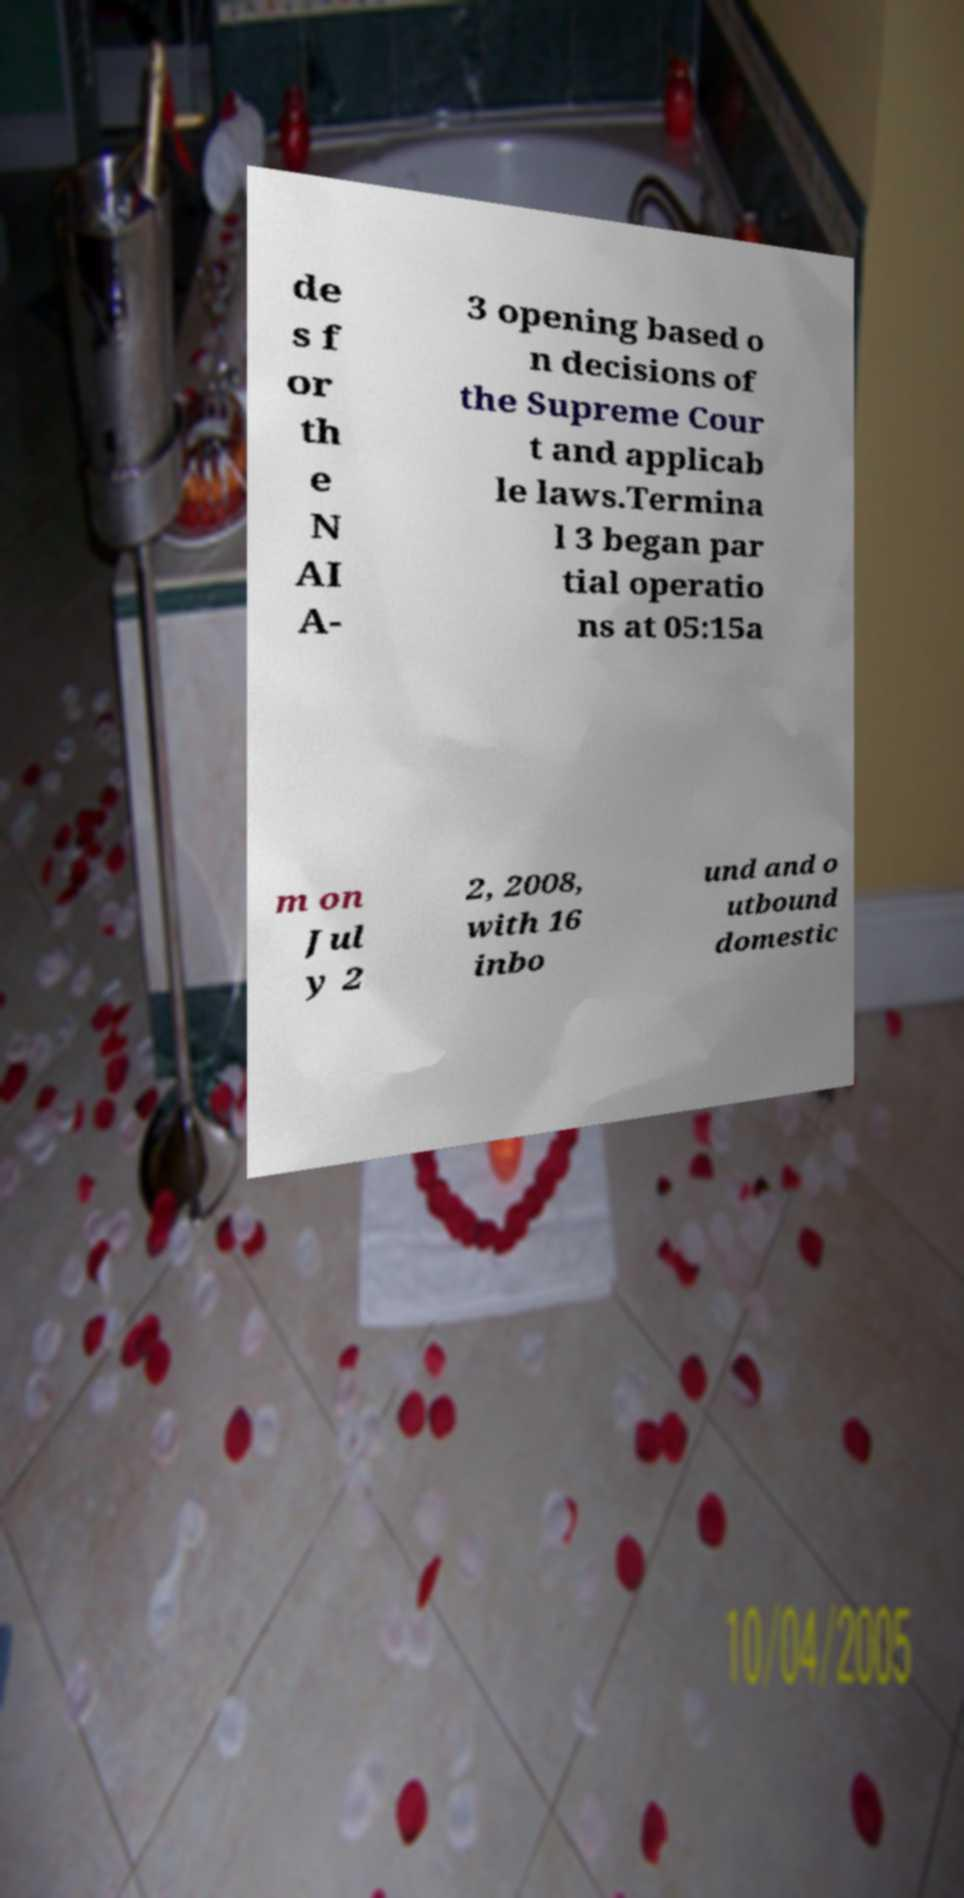There's text embedded in this image that I need extracted. Can you transcribe it verbatim? de s f or th e N AI A- 3 opening based o n decisions of the Supreme Cour t and applicab le laws.Termina l 3 began par tial operatio ns at 05:15a m on Jul y 2 2, 2008, with 16 inbo und and o utbound domestic 